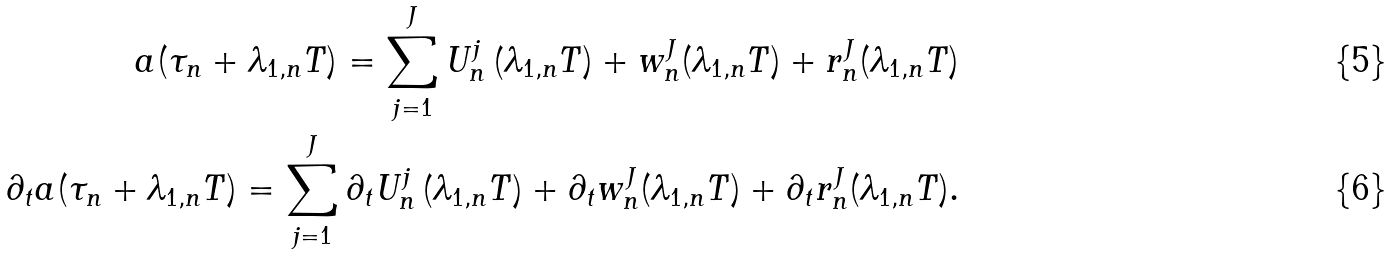<formula> <loc_0><loc_0><loc_500><loc_500>a ( \tau _ { n } + \lambda _ { 1 , n } T ) = \sum _ { j = 1 } ^ { J } U ^ { j } _ { n } \left ( \lambda _ { 1 , n } T \right ) + w _ { n } ^ { J } ( \lambda _ { 1 , n } T ) + r _ { n } ^ { J } ( \lambda _ { 1 , n } T ) \\ \partial _ { t } a ( \tau _ { n } + \lambda _ { 1 , n } T ) = \sum _ { j = 1 } ^ { J } \partial _ { t } U ^ { j } _ { n } \left ( \lambda _ { 1 , n } T \right ) + \partial _ { t } w _ { n } ^ { J } ( \lambda _ { 1 , n } T ) + \partial _ { t } r _ { n } ^ { J } ( \lambda _ { 1 , n } T ) .</formula> 